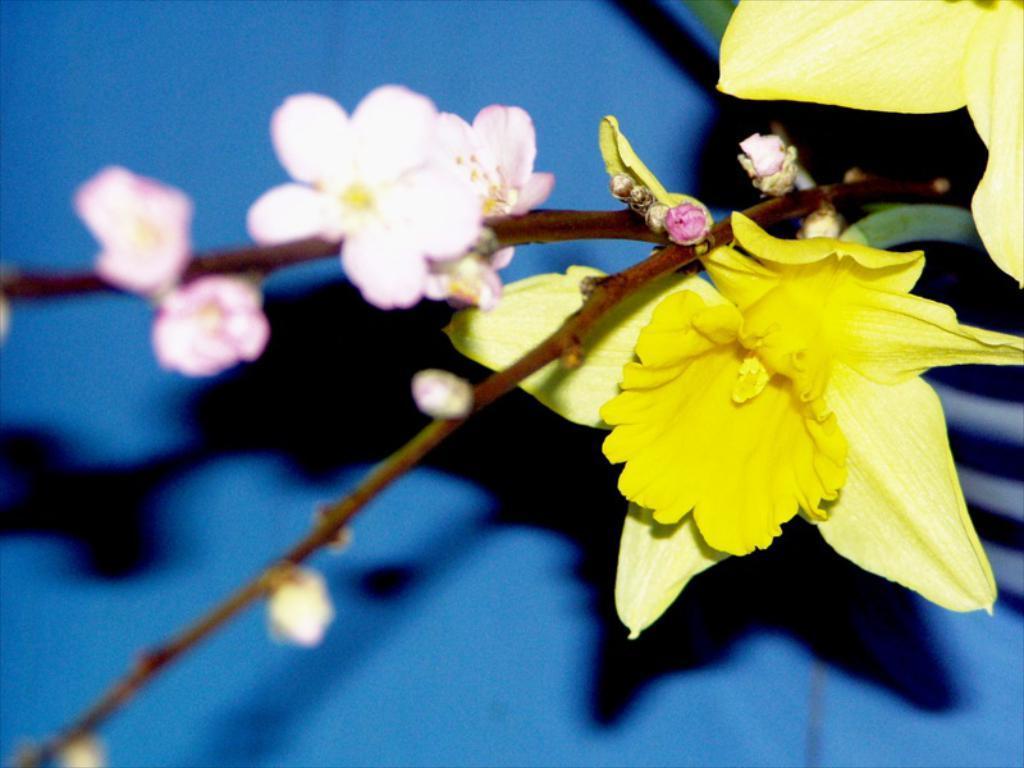How would you summarize this image in a sentence or two? In this picture there are flowers in the image and the background area is blue in color. 